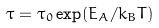Convert formula to latex. <formula><loc_0><loc_0><loc_500><loc_500>\tau = \tau _ { 0 } \exp ( E _ { A } / k _ { B } T )</formula> 